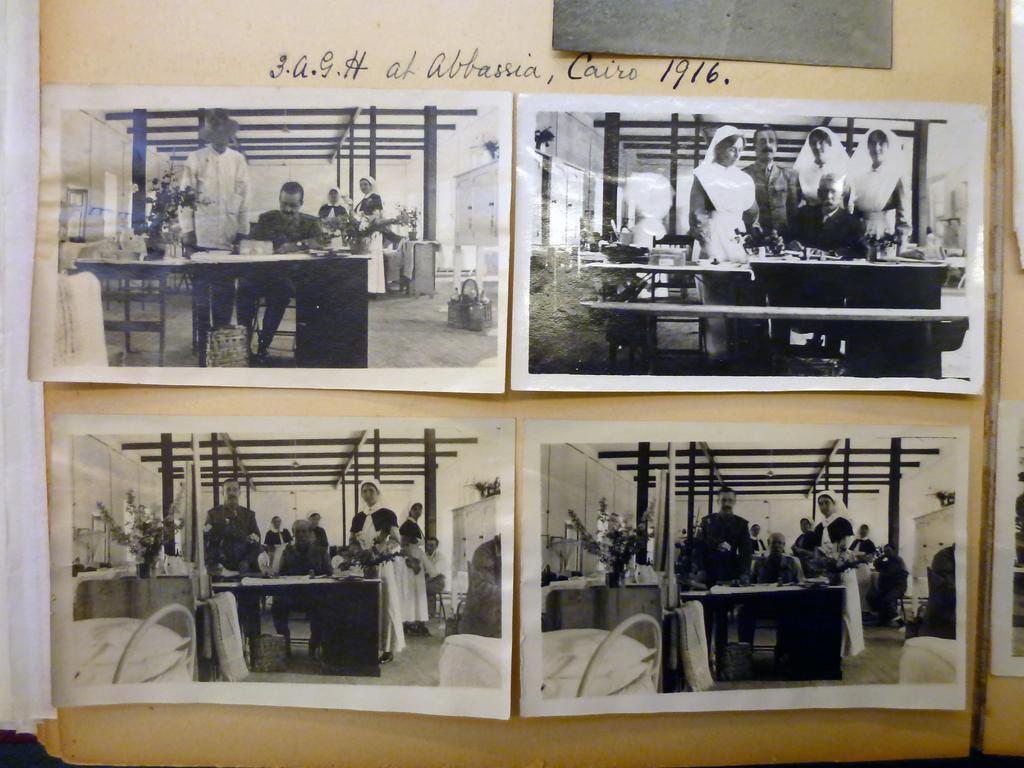Could you give a brief overview of what you see in this image? In this image we can see some photographs and text. In the photographs, there are some persons and other objects. 